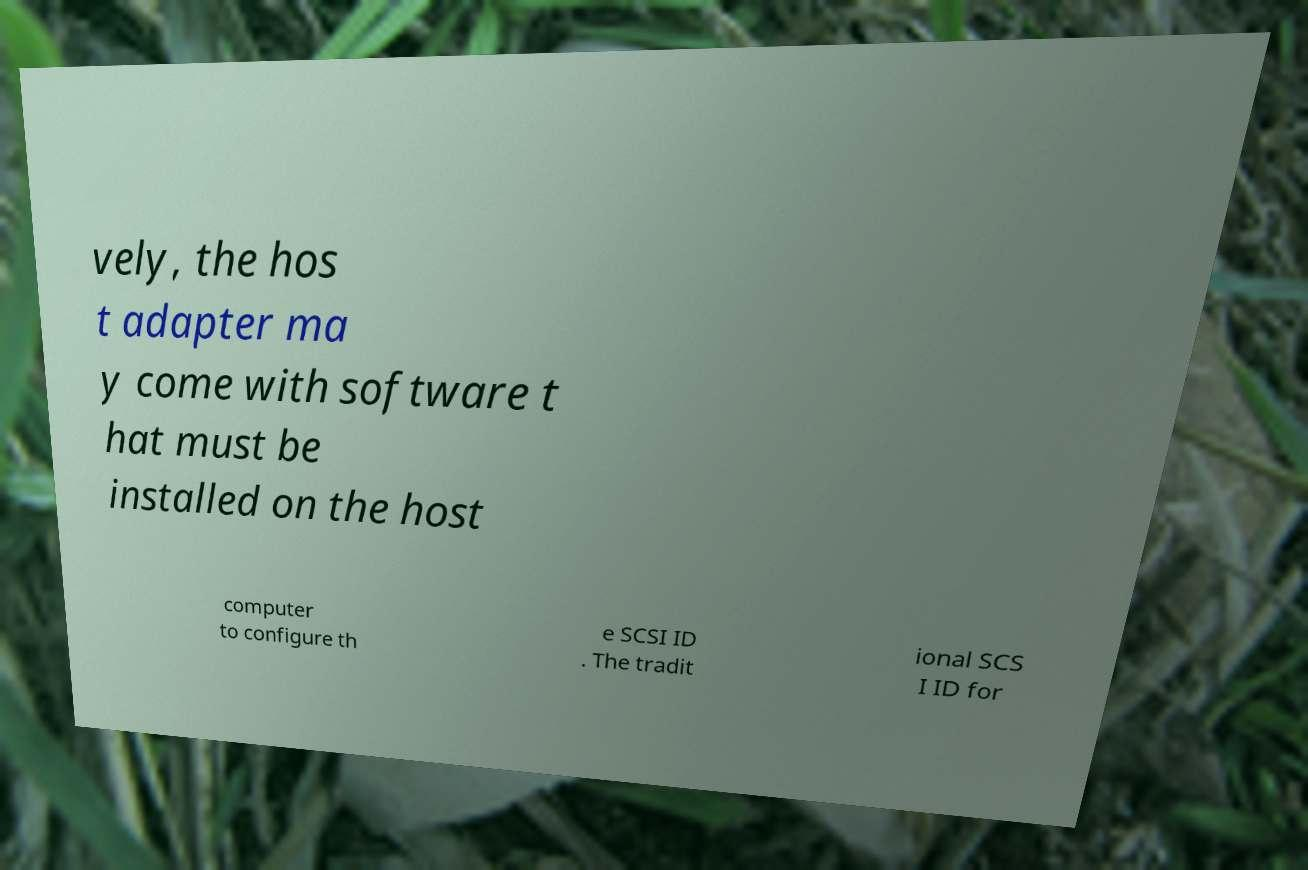Please read and relay the text visible in this image. What does it say? vely, the hos t adapter ma y come with software t hat must be installed on the host computer to configure th e SCSI ID . The tradit ional SCS I ID for 